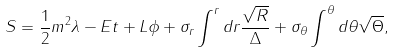Convert formula to latex. <formula><loc_0><loc_0><loc_500><loc_500>S = \frac { 1 } { 2 } m ^ { 2 } \lambda - E t + L \phi + \sigma _ { r } \int ^ { r } d r \frac { \sqrt { R } } { \Delta } + \sigma _ { \theta } \int ^ { \theta } d \theta \sqrt { \Theta } ,</formula> 